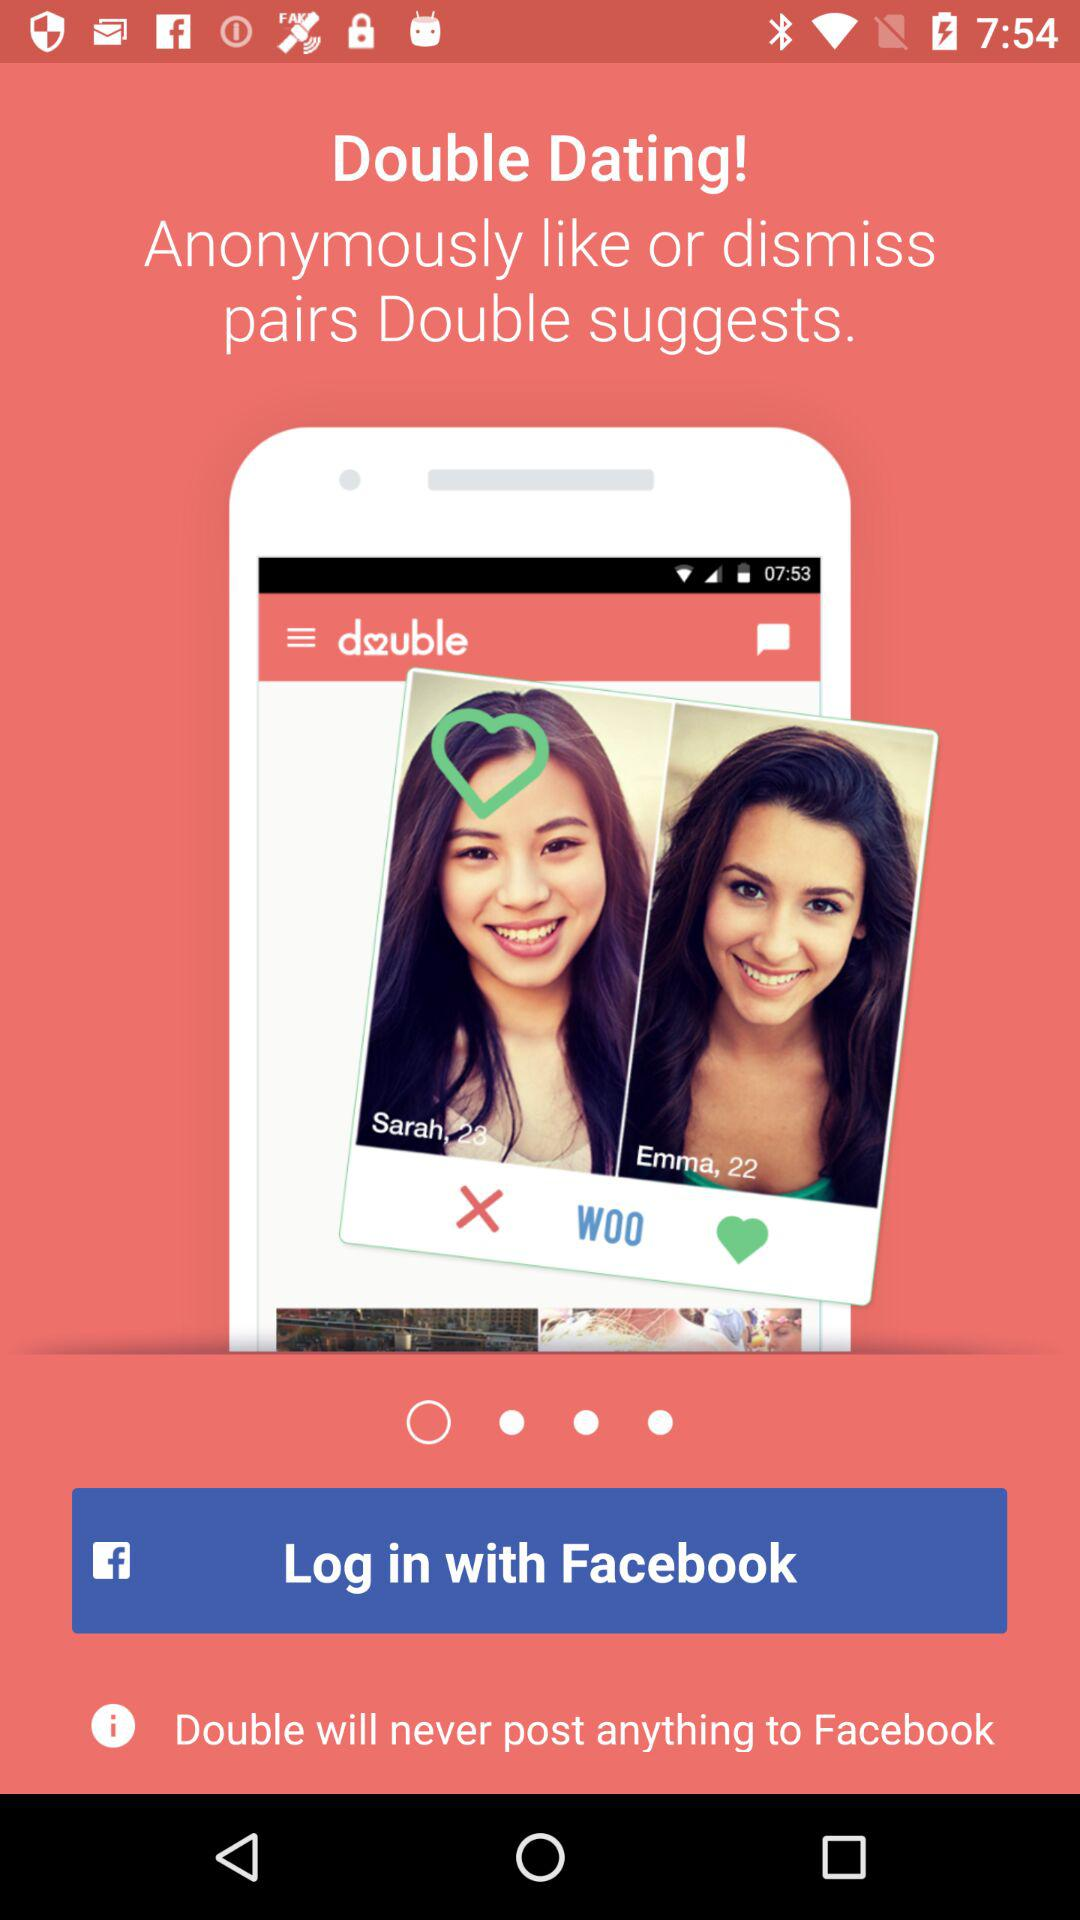On which social media platform will "Double" never post anything? "Double" will never post anything on "Facebook". 